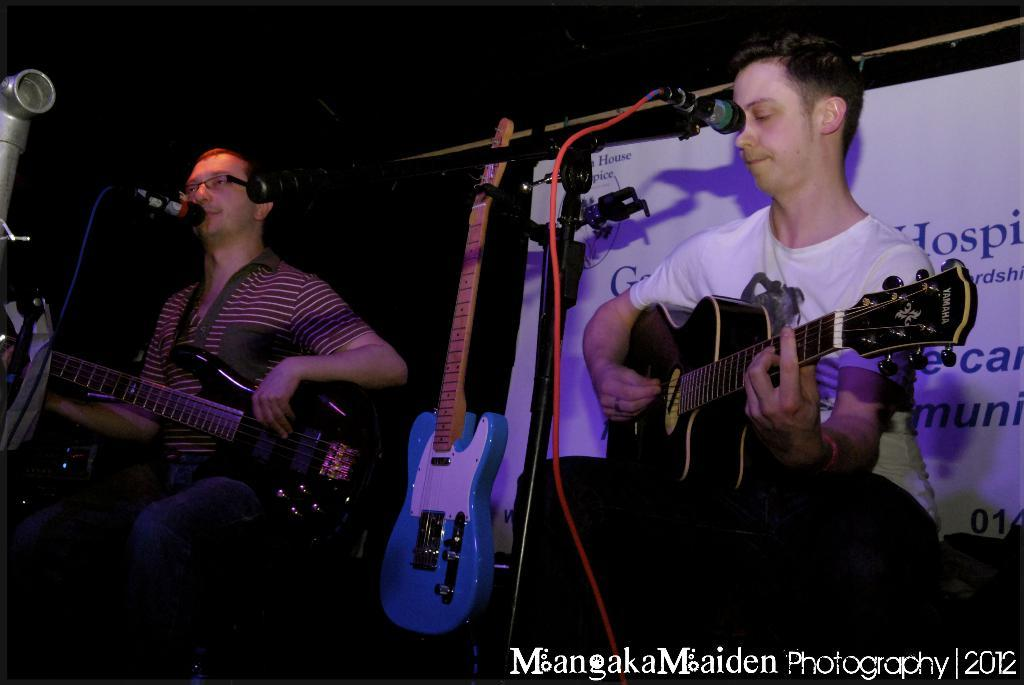How many people are in the image? There are two people in the image. What are the two people doing in the image? The two people are playing guitar. Where are the two people sitting in the image? They are sitting in front of a microphone. What can be seen in the background of the image? There is a banner visible in the background of the image. Can you see any stockings hanging from the ceiling in the image? No, there are no stockings hanging from the ceiling in the image. Is there a swing visible in the image? No, there is no swing visible in the image. 